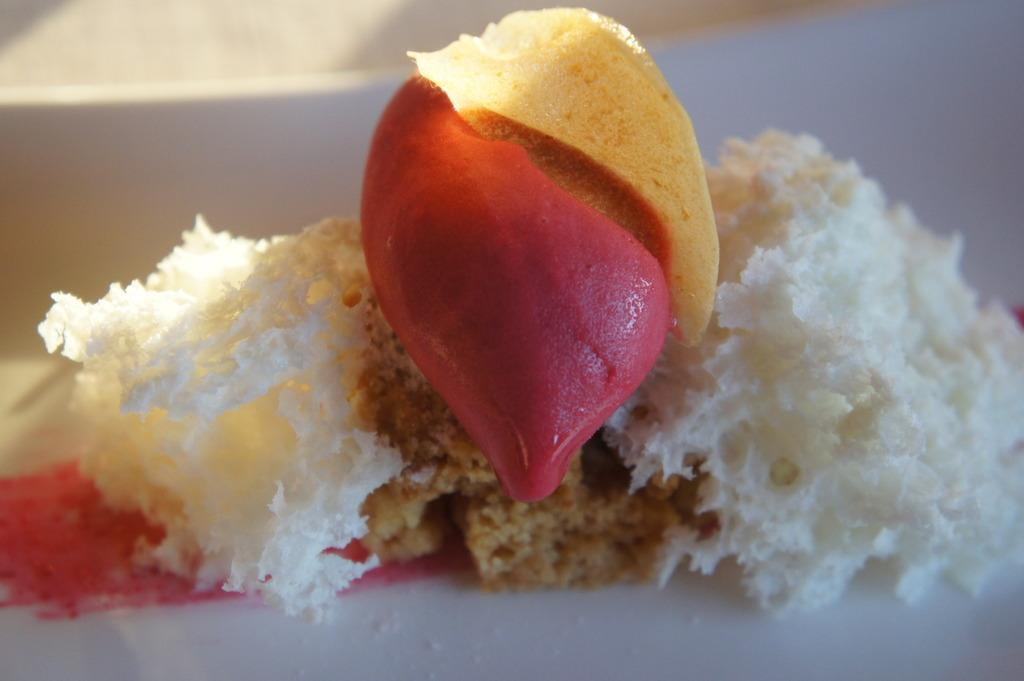What type of food can be seen in the image? There is bread in the image. What other types of food are present in the image besides bread? There is other food in the image. What is the chance of winning the lottery in the image? There is no information about the lottery or winning chances in the image. 